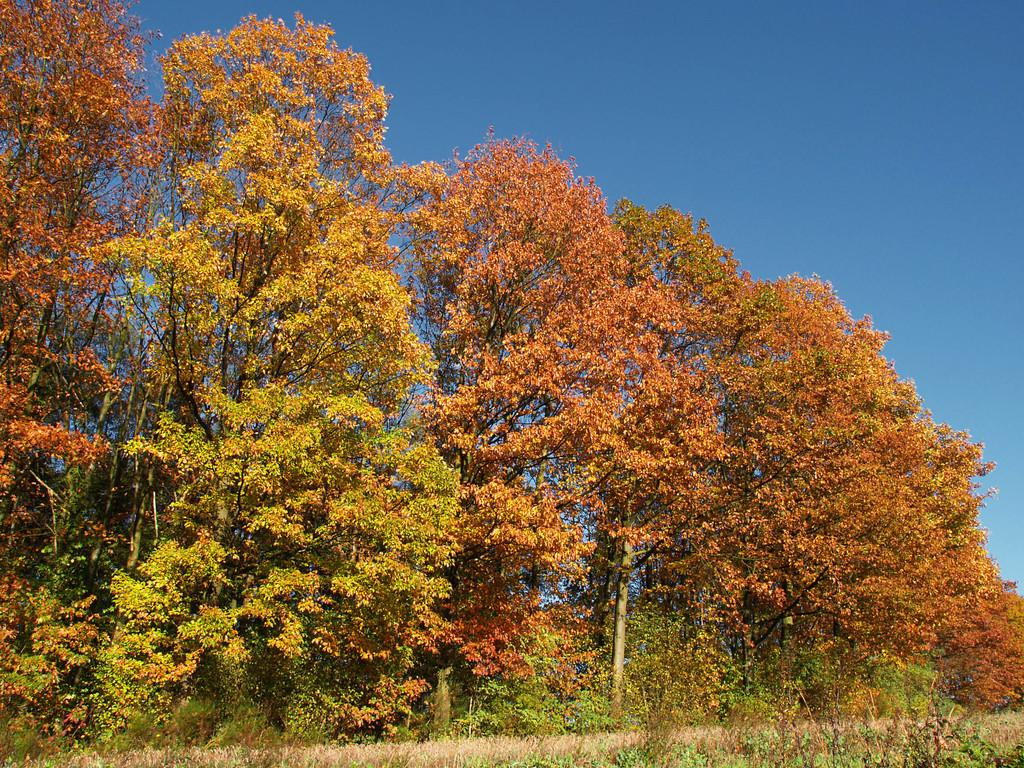What type of vegetation is at the bottom of the image? There is grass and small plants at the bottom of the image. What else can be seen in the background of the image? There are trees and the sky visible in the background of the image. What type of flesh can be seen reacting to the chin in the image? There is no flesh or chin present in the image; it features grass, small plants, trees, and the sky. 